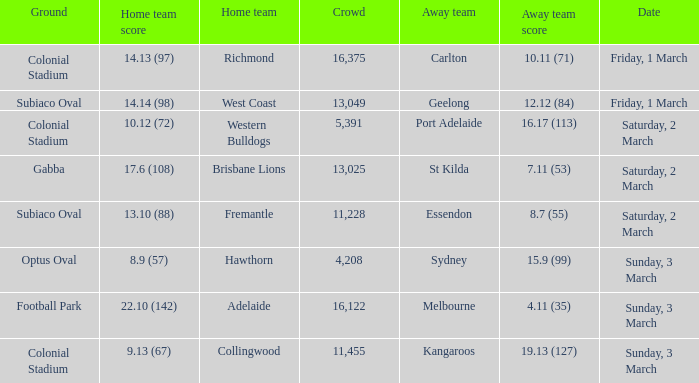Who is the away team when the home team scored 17.6 (108)? St Kilda. 